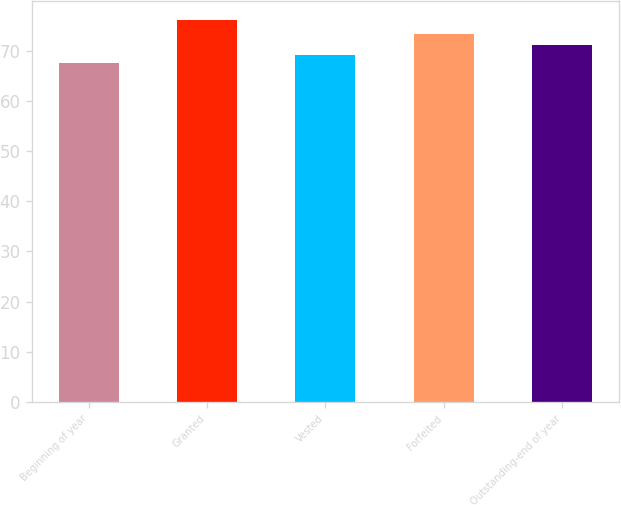Convert chart to OTSL. <chart><loc_0><loc_0><loc_500><loc_500><bar_chart><fcel>Beginning of year<fcel>Granted<fcel>Vested<fcel>Forfeited<fcel>Outstanding-end of year<nl><fcel>67.6<fcel>76.06<fcel>69.12<fcel>73.22<fcel>71.03<nl></chart> 